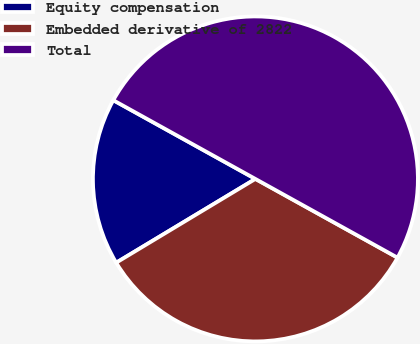<chart> <loc_0><loc_0><loc_500><loc_500><pie_chart><fcel>Equity compensation<fcel>Embedded derivative of 2822<fcel>Total<nl><fcel>16.67%<fcel>33.33%<fcel>50.0%<nl></chart> 